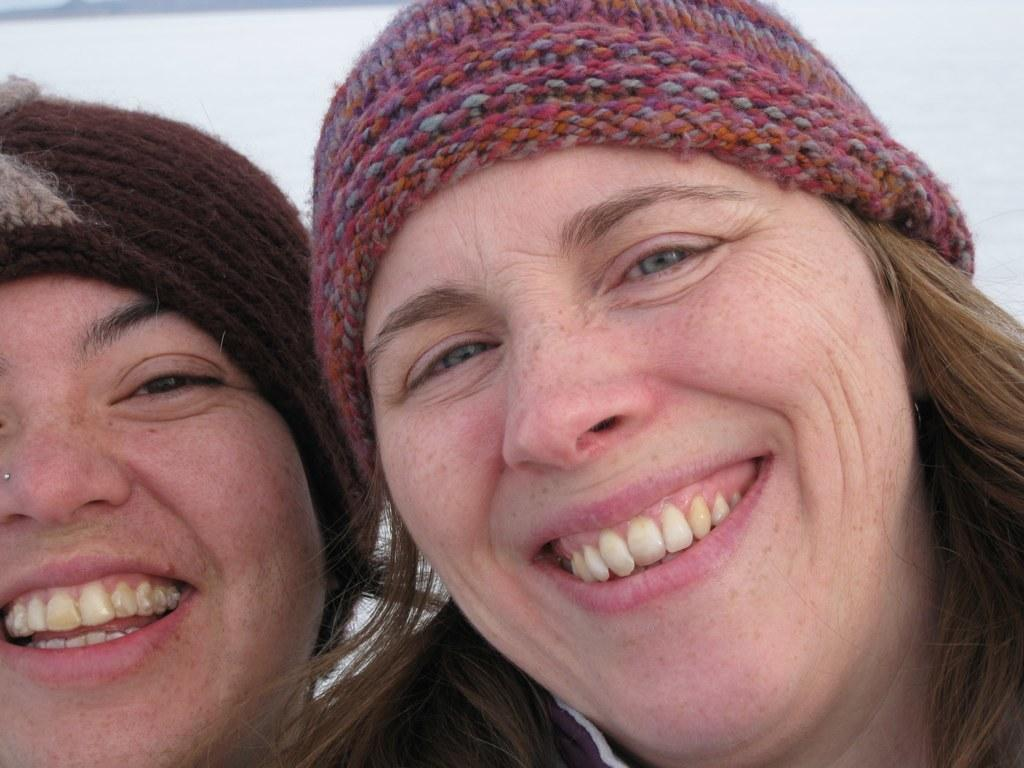How many people are in the image? There are two women in the image. What expressions do the women have? Both women are smiling in the image. What type of headwear are the women wearing? The women are wearing caps on their heads. What type of spark can be seen coming from the women's caps in the image? There is no spark visible in the image; the women are simply wearing caps. 